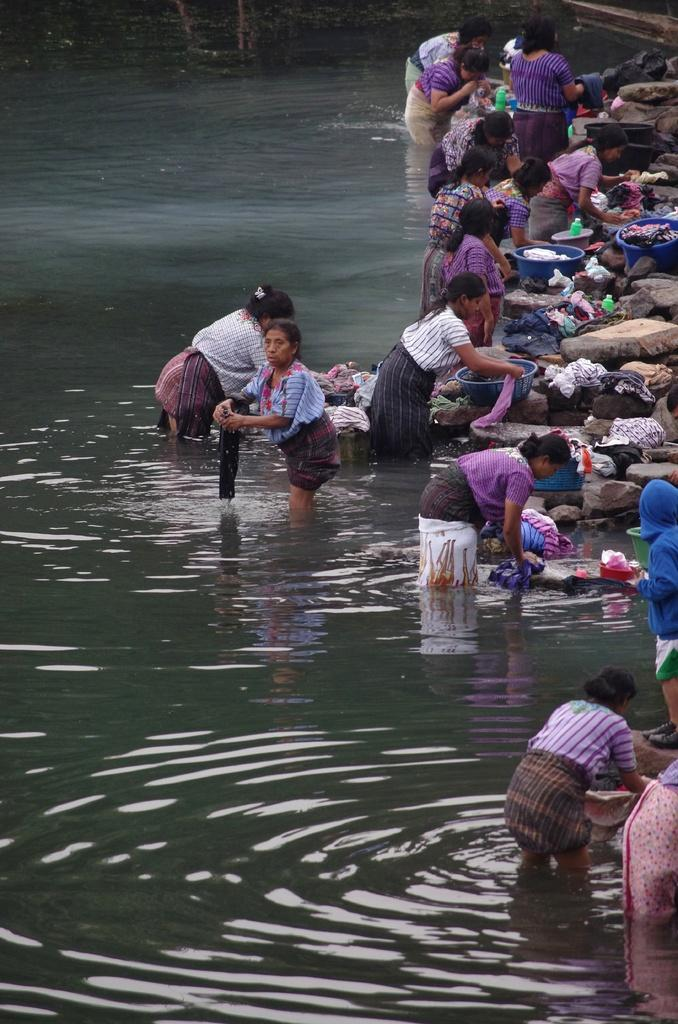Who is present in the image? There are women in the image. What are the women doing in the image? The women are washing clothes in the water. Can you describe the clothing of some of the women? Some of the women are wearing purple clothes. What type of jar is being used by the women to wash their clothes? There is no jar present in the image; the women are washing clothes directly in the water. 